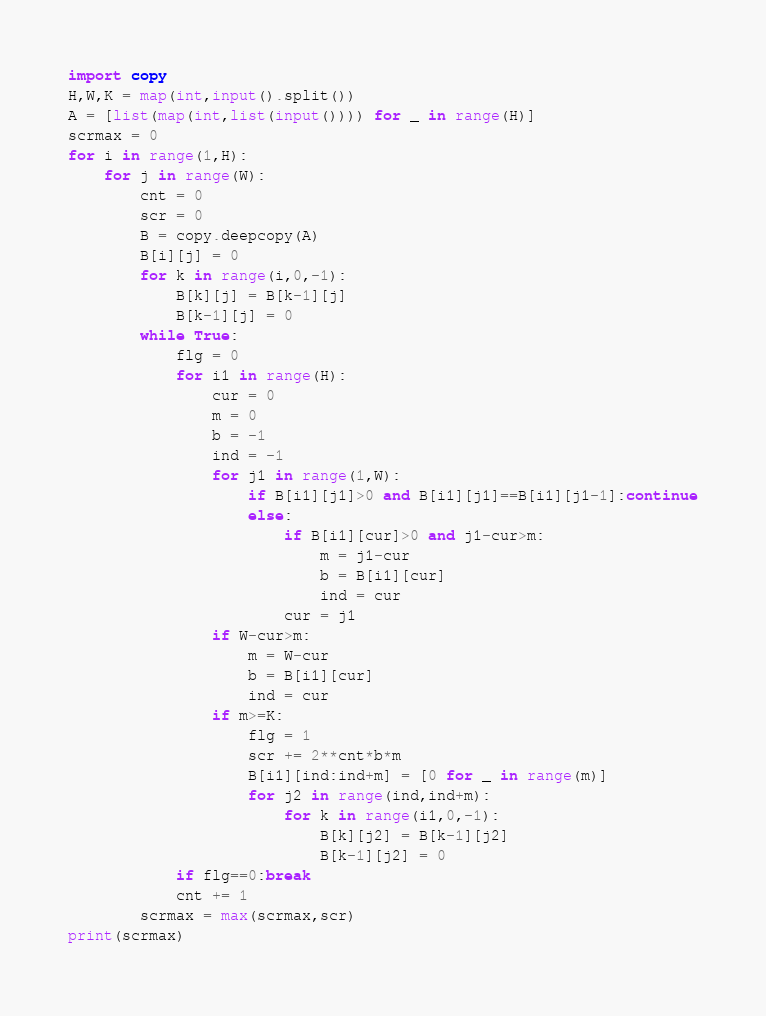<code> <loc_0><loc_0><loc_500><loc_500><_Python_>import copy
H,W,K = map(int,input().split())
A = [list(map(int,list(input()))) for _ in range(H)]
scrmax = 0
for i in range(1,H):
    for j in range(W):
        cnt = 0
        scr = 0
        B = copy.deepcopy(A)
        B[i][j] = 0
        for k in range(i,0,-1):
            B[k][j] = B[k-1][j]
            B[k-1][j] = 0
        while True:
            flg = 0
            for i1 in range(H):
                cur = 0
                m = 0
                b = -1
                ind = -1
                for j1 in range(1,W):
                    if B[i1][j1]>0 and B[i1][j1]==B[i1][j1-1]:continue
                    else:
                        if B[i1][cur]>0 and j1-cur>m:
                            m = j1-cur
                            b = B[i1][cur]
                            ind = cur
                        cur = j1
                if W-cur>m:
                    m = W-cur
                    b = B[i1][cur]
                    ind = cur
                if m>=K:
                    flg = 1
                    scr += 2**cnt*b*m
                    B[i1][ind:ind+m] = [0 for _ in range(m)]
                    for j2 in range(ind,ind+m):
                        for k in range(i1,0,-1):
                            B[k][j2] = B[k-1][j2]
                            B[k-1][j2] = 0
            if flg==0:break
            cnt += 1
        scrmax = max(scrmax,scr)     
print(scrmax)</code> 